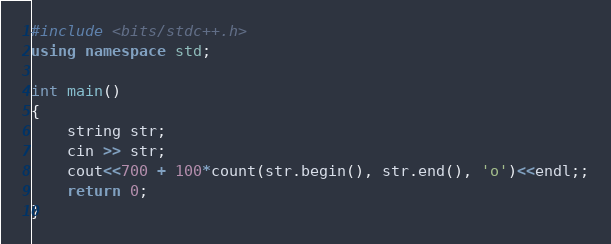Convert code to text. <code><loc_0><loc_0><loc_500><loc_500><_C++_>#include <bits/stdc++.h>
using namespace std;

int main()
{
    string str;
    cin >> str;
    cout<<700 + 100*count(str.begin(), str.end(), 'o')<<endl;;
    return 0;
}
</code> 